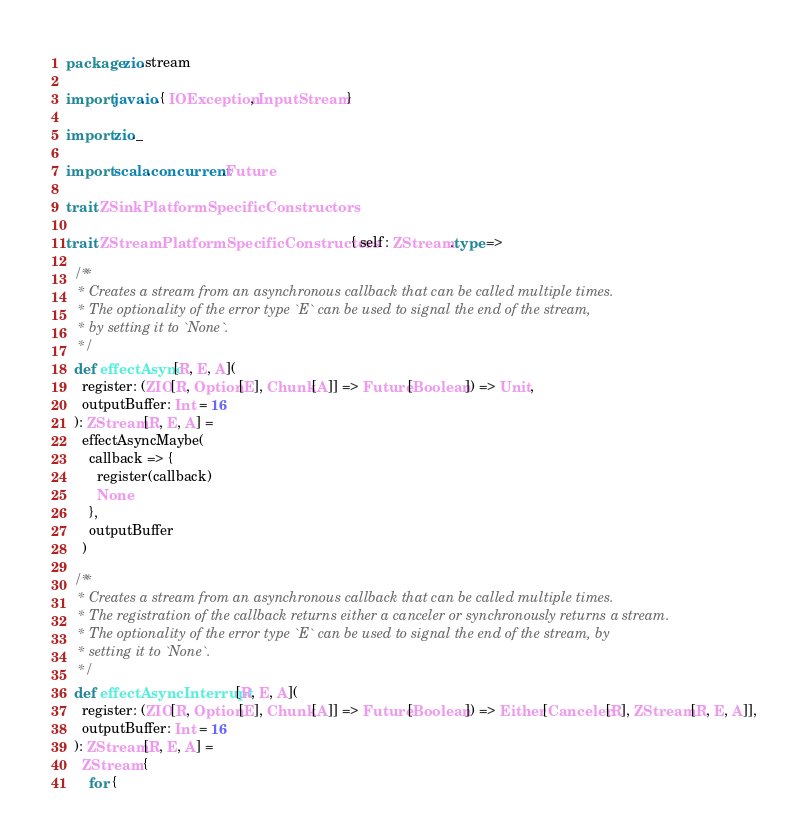Convert code to text. <code><loc_0><loc_0><loc_500><loc_500><_Scala_>package zio.stream

import java.io.{ IOException, InputStream }

import zio._

import scala.concurrent.Future

trait ZSinkPlatformSpecificConstructors

trait ZStreamPlatformSpecificConstructors { self: ZStream.type =>

  /**
   * Creates a stream from an asynchronous callback that can be called multiple times.
   * The optionality of the error type `E` can be used to signal the end of the stream,
   * by setting it to `None`.
   */
  def effectAsync[R, E, A](
    register: (ZIO[R, Option[E], Chunk[A]] => Future[Boolean]) => Unit,
    outputBuffer: Int = 16
  ): ZStream[R, E, A] =
    effectAsyncMaybe(
      callback => {
        register(callback)
        None
      },
      outputBuffer
    )

  /**
   * Creates a stream from an asynchronous callback that can be called multiple times.
   * The registration of the callback returns either a canceler or synchronously returns a stream.
   * The optionality of the error type `E` can be used to signal the end of the stream, by
   * setting it to `None`.
   */
  def effectAsyncInterrupt[R, E, A](
    register: (ZIO[R, Option[E], Chunk[A]] => Future[Boolean]) => Either[Canceler[R], ZStream[R, E, A]],
    outputBuffer: Int = 16
  ): ZStream[R, E, A] =
    ZStream {
      for {</code> 